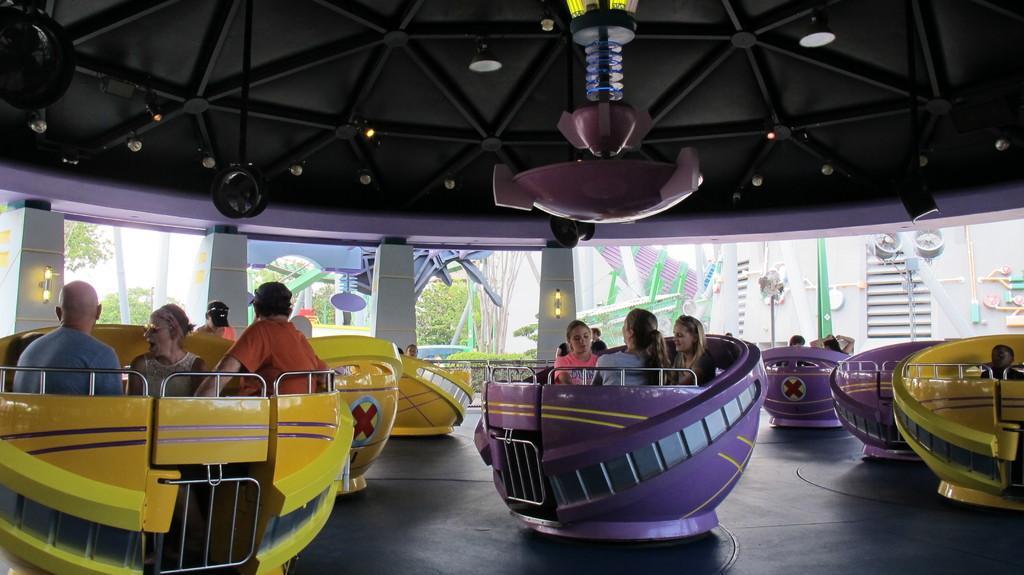How would you summarize this image in a sentence or two? In the image we can see there are people sitting in the cup shaped amusement ride. 